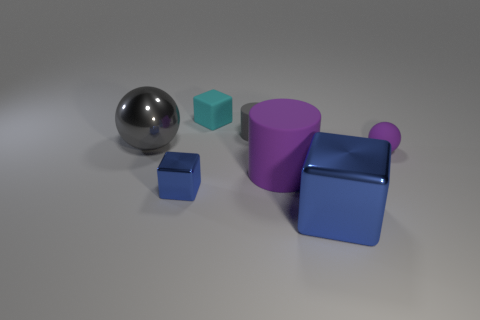Are the objects arranged in a pattern or randomly? The objects appear to be arranged somewhat randomly, without a clear pattern. They are spread out across the surface with varying distances between them, suggesting no intentional arrangement beyond perhaps aesthetic placement for display. 